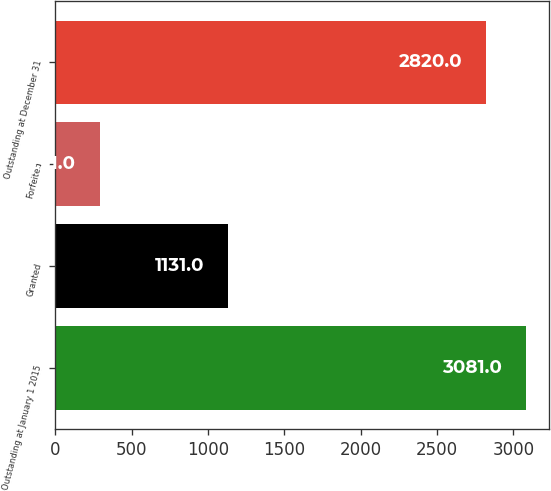Convert chart. <chart><loc_0><loc_0><loc_500><loc_500><bar_chart><fcel>Outstanding at January 1 2015<fcel>Granted<fcel>Forfeited<fcel>Outstanding at December 31<nl><fcel>3081<fcel>1131<fcel>291<fcel>2820<nl></chart> 